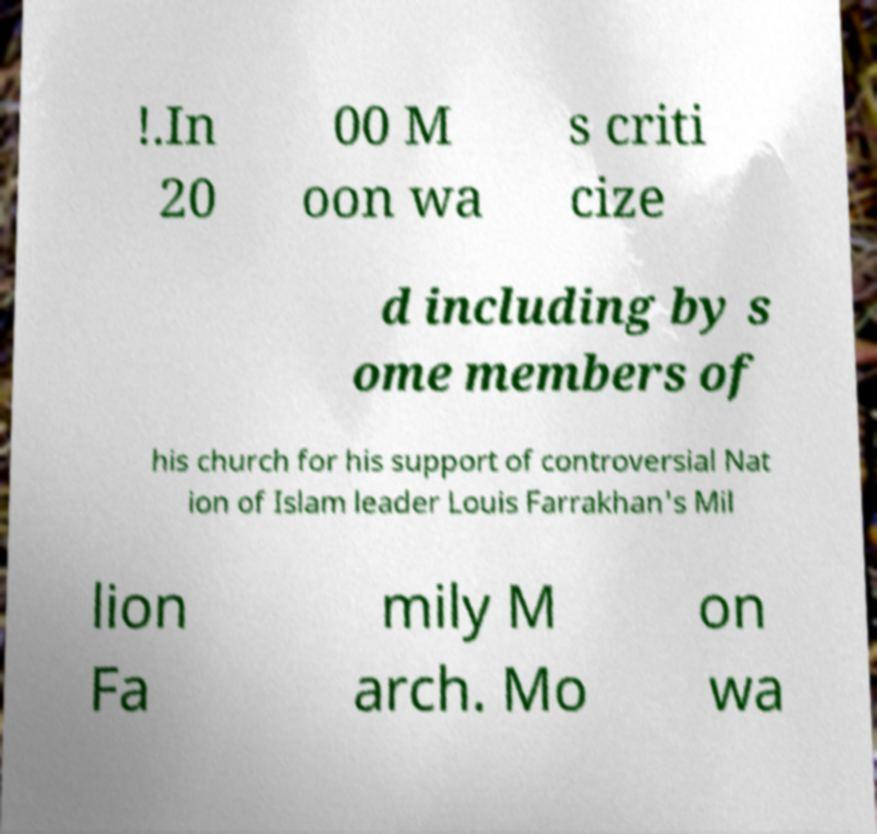Can you read and provide the text displayed in the image?This photo seems to have some interesting text. Can you extract and type it out for me? !.In 20 00 M oon wa s criti cize d including by s ome members of his church for his support of controversial Nat ion of Islam leader Louis Farrakhan's Mil lion Fa mily M arch. Mo on wa 